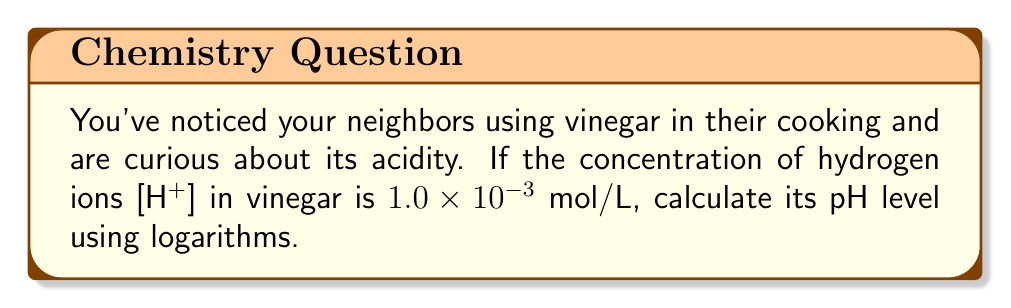Can you solve this math problem? To calculate the pH level, we use the formula:

$$ pH = -\log_{10}[H^+] $$

Where [H+] is the concentration of hydrogen ions in mol/L.

Given: [H+] = $1.0 \times 10^{-3}$ mol/L

Step 1: Substitute the given [H+] value into the pH formula:
$$ pH = -\log_{10}(1.0 \times 10^{-3}) $$

Step 2: Use the logarithm property $\log_a(x^n) = n\log_a(x)$:
$$ pH = -(\log_{10}(1.0) + \log_{10}(10^{-3})) $$

Step 3: Simplify:
$$ pH = -(0 + (-3)) = 3 $$

Therefore, the pH of the vinegar is 3.
Answer: 3 